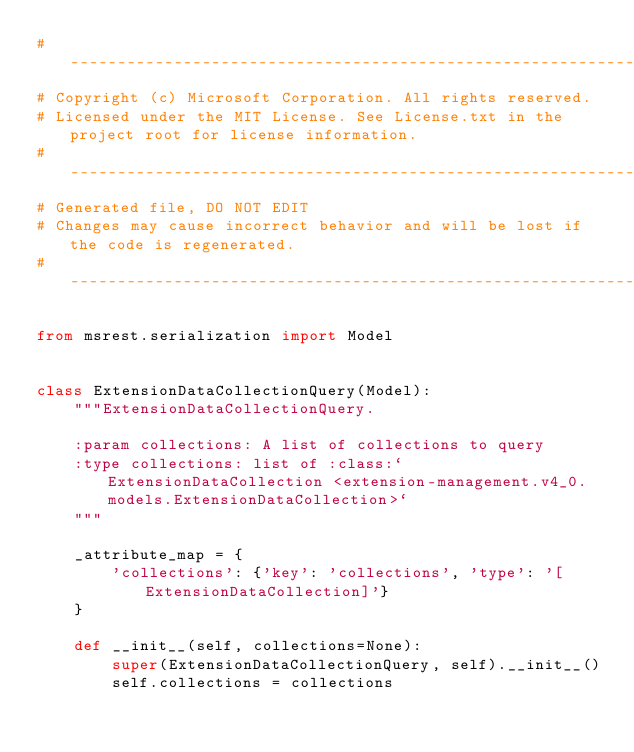Convert code to text. <code><loc_0><loc_0><loc_500><loc_500><_Python_># --------------------------------------------------------------------------------------------
# Copyright (c) Microsoft Corporation. All rights reserved.
# Licensed under the MIT License. See License.txt in the project root for license information.
# --------------------------------------------------------------------------------------------
# Generated file, DO NOT EDIT
# Changes may cause incorrect behavior and will be lost if the code is regenerated.
# --------------------------------------------------------------------------------------------

from msrest.serialization import Model


class ExtensionDataCollectionQuery(Model):
    """ExtensionDataCollectionQuery.

    :param collections: A list of collections to query
    :type collections: list of :class:`ExtensionDataCollection <extension-management.v4_0.models.ExtensionDataCollection>`
    """

    _attribute_map = {
        'collections': {'key': 'collections', 'type': '[ExtensionDataCollection]'}
    }

    def __init__(self, collections=None):
        super(ExtensionDataCollectionQuery, self).__init__()
        self.collections = collections
</code> 